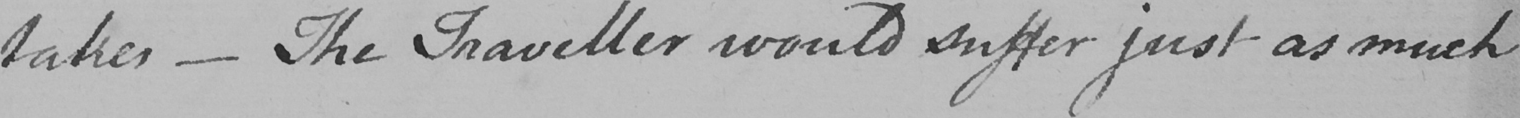What text is written in this handwritten line? takes  _  The Traveller would suffer just as much 